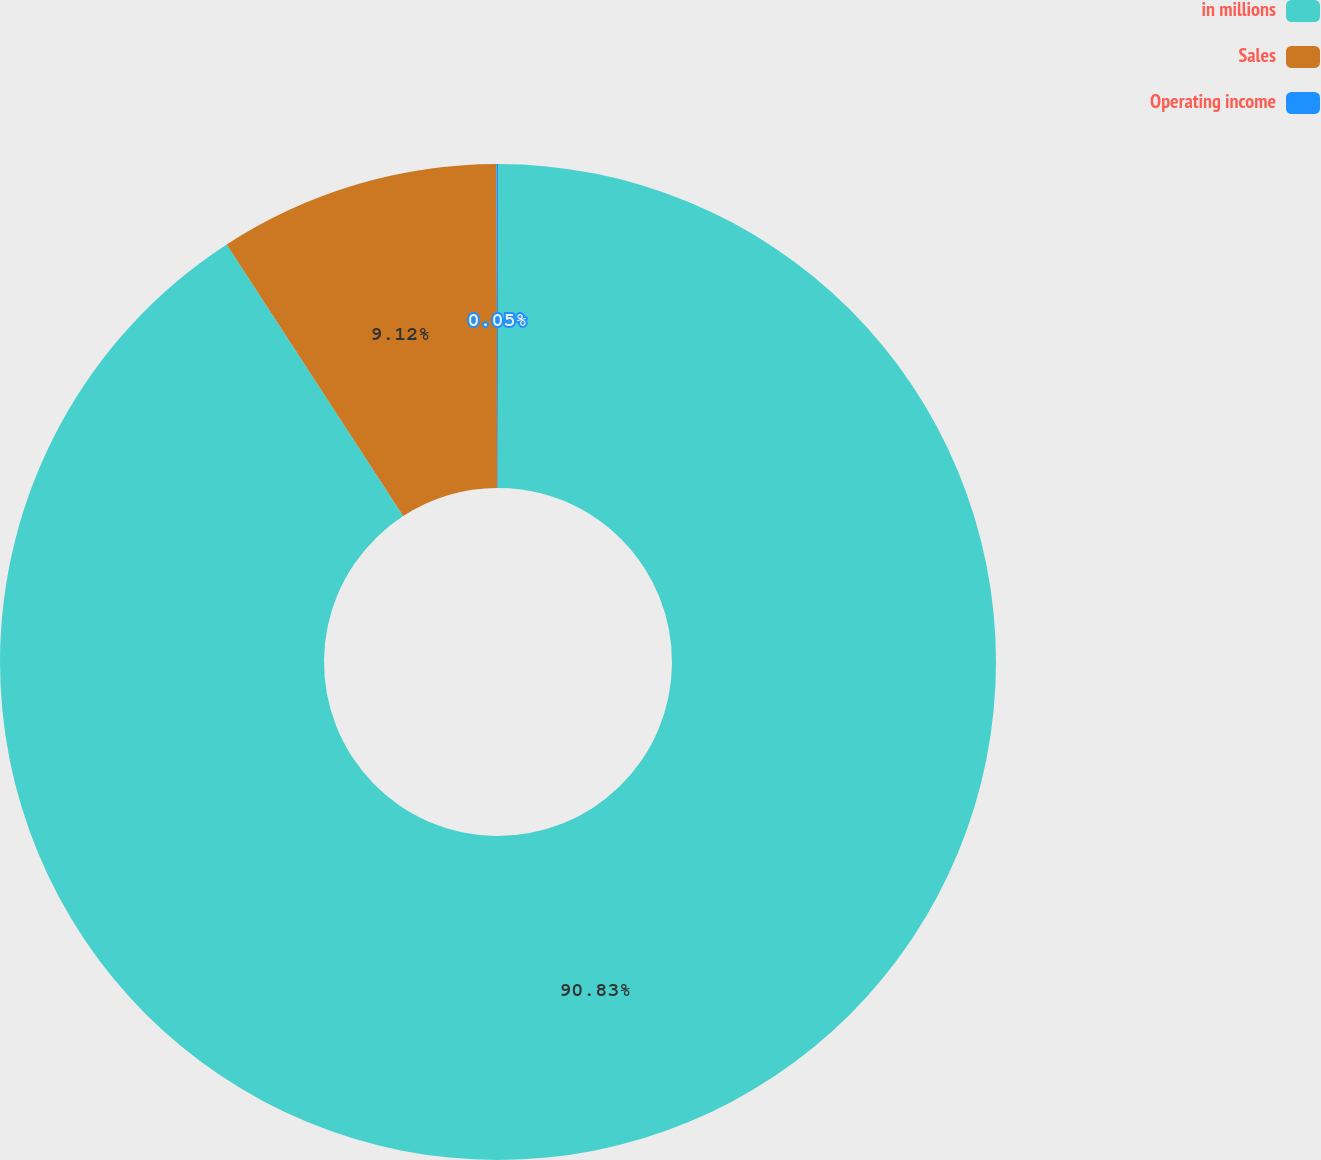<chart> <loc_0><loc_0><loc_500><loc_500><pie_chart><fcel>in millions<fcel>Sales<fcel>Operating income<nl><fcel>90.83%<fcel>9.12%<fcel>0.05%<nl></chart> 